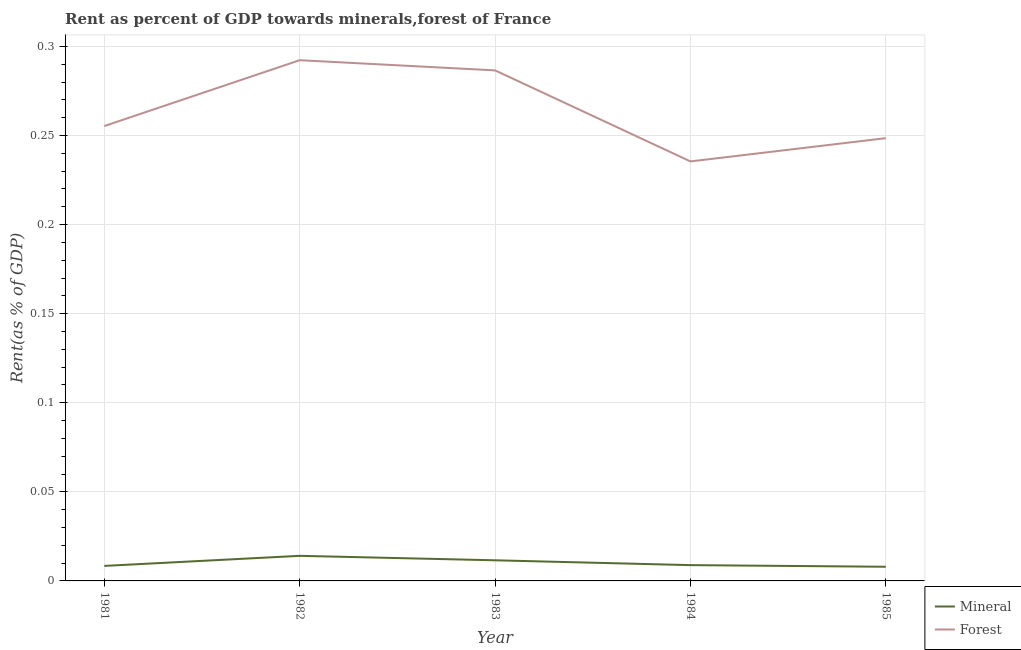Does the line corresponding to forest rent intersect with the line corresponding to mineral rent?
Give a very brief answer. No. Is the number of lines equal to the number of legend labels?
Offer a very short reply. Yes. What is the forest rent in 1981?
Your answer should be very brief. 0.26. Across all years, what is the maximum mineral rent?
Provide a short and direct response. 0.01. Across all years, what is the minimum mineral rent?
Provide a short and direct response. 0.01. In which year was the mineral rent maximum?
Offer a very short reply. 1982. In which year was the mineral rent minimum?
Make the answer very short. 1985. What is the total mineral rent in the graph?
Provide a succinct answer. 0.05. What is the difference between the forest rent in 1983 and that in 1985?
Offer a terse response. 0.04. What is the difference between the forest rent in 1983 and the mineral rent in 1982?
Your answer should be compact. 0.27. What is the average forest rent per year?
Provide a short and direct response. 0.26. In the year 1984, what is the difference between the forest rent and mineral rent?
Offer a terse response. 0.23. What is the ratio of the mineral rent in 1982 to that in 1985?
Offer a terse response. 1.77. Is the forest rent in 1981 less than that in 1984?
Provide a succinct answer. No. Is the difference between the forest rent in 1983 and 1984 greater than the difference between the mineral rent in 1983 and 1984?
Provide a short and direct response. Yes. What is the difference between the highest and the second highest forest rent?
Your response must be concise. 0.01. What is the difference between the highest and the lowest forest rent?
Ensure brevity in your answer.  0.06. Is the sum of the mineral rent in 1984 and 1985 greater than the maximum forest rent across all years?
Offer a very short reply. No. Does the forest rent monotonically increase over the years?
Give a very brief answer. No. Is the forest rent strictly greater than the mineral rent over the years?
Your answer should be compact. Yes. What is the difference between two consecutive major ticks on the Y-axis?
Offer a very short reply. 0.05. Does the graph contain grids?
Provide a short and direct response. Yes. Where does the legend appear in the graph?
Your answer should be very brief. Bottom right. What is the title of the graph?
Offer a very short reply. Rent as percent of GDP towards minerals,forest of France. Does "Primary" appear as one of the legend labels in the graph?
Provide a succinct answer. No. What is the label or title of the X-axis?
Offer a terse response. Year. What is the label or title of the Y-axis?
Your response must be concise. Rent(as % of GDP). What is the Rent(as % of GDP) of Mineral in 1981?
Offer a very short reply. 0.01. What is the Rent(as % of GDP) of Forest in 1981?
Offer a very short reply. 0.26. What is the Rent(as % of GDP) in Mineral in 1982?
Offer a terse response. 0.01. What is the Rent(as % of GDP) in Forest in 1982?
Offer a terse response. 0.29. What is the Rent(as % of GDP) of Mineral in 1983?
Make the answer very short. 0.01. What is the Rent(as % of GDP) of Forest in 1983?
Provide a short and direct response. 0.29. What is the Rent(as % of GDP) in Mineral in 1984?
Make the answer very short. 0.01. What is the Rent(as % of GDP) in Forest in 1984?
Ensure brevity in your answer.  0.24. What is the Rent(as % of GDP) of Mineral in 1985?
Your answer should be compact. 0.01. What is the Rent(as % of GDP) in Forest in 1985?
Your answer should be very brief. 0.25. Across all years, what is the maximum Rent(as % of GDP) in Mineral?
Your answer should be very brief. 0.01. Across all years, what is the maximum Rent(as % of GDP) in Forest?
Make the answer very short. 0.29. Across all years, what is the minimum Rent(as % of GDP) of Mineral?
Make the answer very short. 0.01. Across all years, what is the minimum Rent(as % of GDP) of Forest?
Your answer should be very brief. 0.24. What is the total Rent(as % of GDP) in Mineral in the graph?
Keep it short and to the point. 0.05. What is the total Rent(as % of GDP) in Forest in the graph?
Offer a very short reply. 1.32. What is the difference between the Rent(as % of GDP) in Mineral in 1981 and that in 1982?
Offer a very short reply. -0.01. What is the difference between the Rent(as % of GDP) in Forest in 1981 and that in 1982?
Give a very brief answer. -0.04. What is the difference between the Rent(as % of GDP) of Mineral in 1981 and that in 1983?
Keep it short and to the point. -0. What is the difference between the Rent(as % of GDP) in Forest in 1981 and that in 1983?
Ensure brevity in your answer.  -0.03. What is the difference between the Rent(as % of GDP) of Mineral in 1981 and that in 1984?
Provide a succinct answer. -0. What is the difference between the Rent(as % of GDP) in Forest in 1981 and that in 1984?
Your answer should be very brief. 0.02. What is the difference between the Rent(as % of GDP) of Forest in 1981 and that in 1985?
Give a very brief answer. 0.01. What is the difference between the Rent(as % of GDP) in Mineral in 1982 and that in 1983?
Your answer should be very brief. 0. What is the difference between the Rent(as % of GDP) of Forest in 1982 and that in 1983?
Provide a succinct answer. 0.01. What is the difference between the Rent(as % of GDP) in Mineral in 1982 and that in 1984?
Keep it short and to the point. 0.01. What is the difference between the Rent(as % of GDP) of Forest in 1982 and that in 1984?
Make the answer very short. 0.06. What is the difference between the Rent(as % of GDP) in Mineral in 1982 and that in 1985?
Give a very brief answer. 0.01. What is the difference between the Rent(as % of GDP) of Forest in 1982 and that in 1985?
Your response must be concise. 0.04. What is the difference between the Rent(as % of GDP) in Mineral in 1983 and that in 1984?
Provide a short and direct response. 0. What is the difference between the Rent(as % of GDP) of Forest in 1983 and that in 1984?
Your answer should be compact. 0.05. What is the difference between the Rent(as % of GDP) in Mineral in 1983 and that in 1985?
Give a very brief answer. 0. What is the difference between the Rent(as % of GDP) of Forest in 1983 and that in 1985?
Your response must be concise. 0.04. What is the difference between the Rent(as % of GDP) in Mineral in 1984 and that in 1985?
Offer a very short reply. 0. What is the difference between the Rent(as % of GDP) of Forest in 1984 and that in 1985?
Ensure brevity in your answer.  -0.01. What is the difference between the Rent(as % of GDP) in Mineral in 1981 and the Rent(as % of GDP) in Forest in 1982?
Provide a succinct answer. -0.28. What is the difference between the Rent(as % of GDP) of Mineral in 1981 and the Rent(as % of GDP) of Forest in 1983?
Ensure brevity in your answer.  -0.28. What is the difference between the Rent(as % of GDP) of Mineral in 1981 and the Rent(as % of GDP) of Forest in 1984?
Your answer should be compact. -0.23. What is the difference between the Rent(as % of GDP) in Mineral in 1981 and the Rent(as % of GDP) in Forest in 1985?
Your answer should be very brief. -0.24. What is the difference between the Rent(as % of GDP) in Mineral in 1982 and the Rent(as % of GDP) in Forest in 1983?
Provide a succinct answer. -0.27. What is the difference between the Rent(as % of GDP) of Mineral in 1982 and the Rent(as % of GDP) of Forest in 1984?
Provide a short and direct response. -0.22. What is the difference between the Rent(as % of GDP) of Mineral in 1982 and the Rent(as % of GDP) of Forest in 1985?
Make the answer very short. -0.23. What is the difference between the Rent(as % of GDP) in Mineral in 1983 and the Rent(as % of GDP) in Forest in 1984?
Ensure brevity in your answer.  -0.22. What is the difference between the Rent(as % of GDP) in Mineral in 1983 and the Rent(as % of GDP) in Forest in 1985?
Provide a succinct answer. -0.24. What is the difference between the Rent(as % of GDP) of Mineral in 1984 and the Rent(as % of GDP) of Forest in 1985?
Ensure brevity in your answer.  -0.24. What is the average Rent(as % of GDP) of Mineral per year?
Offer a very short reply. 0.01. What is the average Rent(as % of GDP) in Forest per year?
Provide a short and direct response. 0.26. In the year 1981, what is the difference between the Rent(as % of GDP) of Mineral and Rent(as % of GDP) of Forest?
Give a very brief answer. -0.25. In the year 1982, what is the difference between the Rent(as % of GDP) in Mineral and Rent(as % of GDP) in Forest?
Make the answer very short. -0.28. In the year 1983, what is the difference between the Rent(as % of GDP) in Mineral and Rent(as % of GDP) in Forest?
Your answer should be compact. -0.28. In the year 1984, what is the difference between the Rent(as % of GDP) in Mineral and Rent(as % of GDP) in Forest?
Provide a succinct answer. -0.23. In the year 1985, what is the difference between the Rent(as % of GDP) in Mineral and Rent(as % of GDP) in Forest?
Offer a very short reply. -0.24. What is the ratio of the Rent(as % of GDP) of Mineral in 1981 to that in 1982?
Your answer should be very brief. 0.6. What is the ratio of the Rent(as % of GDP) of Forest in 1981 to that in 1982?
Offer a very short reply. 0.87. What is the ratio of the Rent(as % of GDP) of Mineral in 1981 to that in 1983?
Keep it short and to the point. 0.73. What is the ratio of the Rent(as % of GDP) of Forest in 1981 to that in 1983?
Your response must be concise. 0.89. What is the ratio of the Rent(as % of GDP) in Mineral in 1981 to that in 1984?
Ensure brevity in your answer.  0.95. What is the ratio of the Rent(as % of GDP) in Forest in 1981 to that in 1984?
Your answer should be very brief. 1.08. What is the ratio of the Rent(as % of GDP) in Mineral in 1981 to that in 1985?
Offer a very short reply. 1.06. What is the ratio of the Rent(as % of GDP) of Forest in 1981 to that in 1985?
Ensure brevity in your answer.  1.03. What is the ratio of the Rent(as % of GDP) in Mineral in 1982 to that in 1983?
Your answer should be compact. 1.22. What is the ratio of the Rent(as % of GDP) in Forest in 1982 to that in 1983?
Offer a very short reply. 1.02. What is the ratio of the Rent(as % of GDP) of Mineral in 1982 to that in 1984?
Your answer should be compact. 1.59. What is the ratio of the Rent(as % of GDP) of Forest in 1982 to that in 1984?
Provide a succinct answer. 1.24. What is the ratio of the Rent(as % of GDP) in Mineral in 1982 to that in 1985?
Give a very brief answer. 1.77. What is the ratio of the Rent(as % of GDP) in Forest in 1982 to that in 1985?
Make the answer very short. 1.18. What is the ratio of the Rent(as % of GDP) of Mineral in 1983 to that in 1984?
Make the answer very short. 1.31. What is the ratio of the Rent(as % of GDP) of Forest in 1983 to that in 1984?
Make the answer very short. 1.22. What is the ratio of the Rent(as % of GDP) of Mineral in 1983 to that in 1985?
Your answer should be very brief. 1.46. What is the ratio of the Rent(as % of GDP) of Forest in 1983 to that in 1985?
Your answer should be compact. 1.15. What is the ratio of the Rent(as % of GDP) in Mineral in 1984 to that in 1985?
Offer a very short reply. 1.11. What is the ratio of the Rent(as % of GDP) in Forest in 1984 to that in 1985?
Provide a succinct answer. 0.95. What is the difference between the highest and the second highest Rent(as % of GDP) in Mineral?
Provide a succinct answer. 0. What is the difference between the highest and the second highest Rent(as % of GDP) in Forest?
Your response must be concise. 0.01. What is the difference between the highest and the lowest Rent(as % of GDP) of Mineral?
Offer a terse response. 0.01. What is the difference between the highest and the lowest Rent(as % of GDP) in Forest?
Make the answer very short. 0.06. 